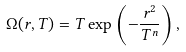<formula> <loc_0><loc_0><loc_500><loc_500>\Omega ( r , T ) = T \exp \left ( - \frac { r ^ { 2 } } { T ^ { n } } \right ) ,</formula> 